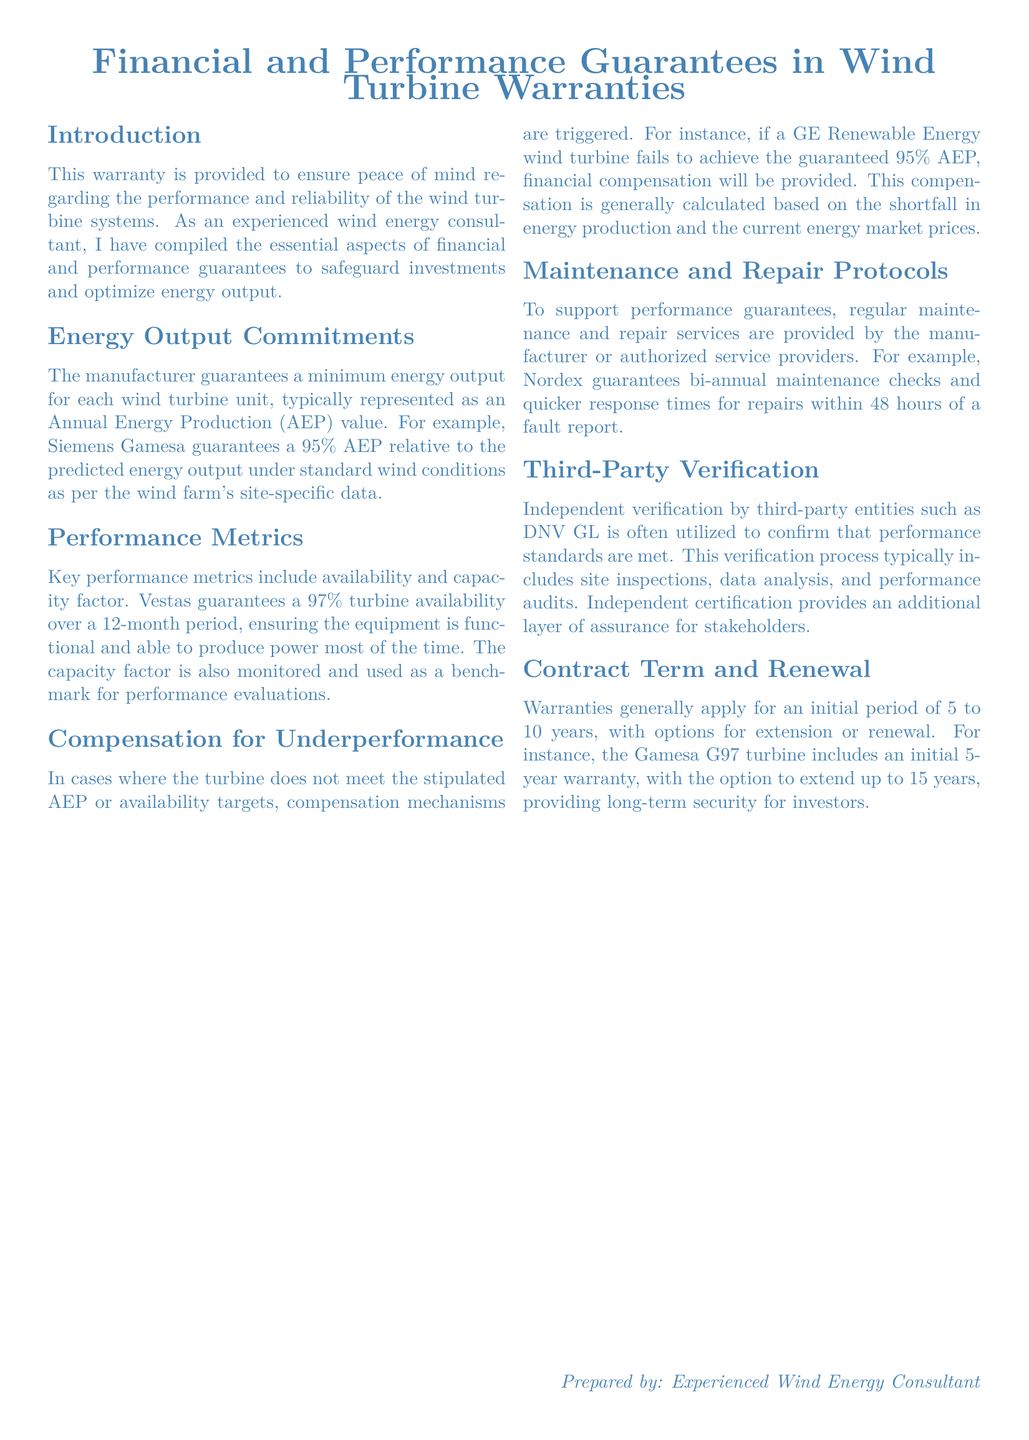What is the minimum energy output guarantee? The document states that the manufacturer guarantees a minimum energy output typically represented as an Annual Energy Production (AEP) value, such as a 95% AEP relative to predicted energy output.
Answer: 95% What is the turbine availability guarantee provided by Vestas? The document specifies that Vestas guarantees a turbine availability of 97% over a 12-month period.
Answer: 97% What is the compensation for a turbine failing to meet AEP? The document mentions that compensation is provided, typically calculated based on the shortfall in energy production and current market prices.
Answer: Financial compensation How often are maintenance checks guaranteed by Nordex? According to the document, Nordex guarantees bi-annual maintenance checks to support performance.
Answer: Bi-annual What is the initial warranty period for the Gamesa G97 turbine? The document states that the Gamesa G97 turbine includes an initial 5-year warranty.
Answer: 5 years Who provides third-party verification for performance standards? The document notes that independent verification is often performed by entities such as DNV GL to confirm performance standards.
Answer: DNV GL What is the capacity factor used for in performance evaluations? The document states capacity factor is monitored and used as a benchmark for performance evaluations for wind turbines.
Answer: Performance evaluations What is the maximum duration for warranty extension mentioned? The document indicates that the warranty can be extended up to 15 years for the Gamesa G97 turbine.
Answer: 15 years 